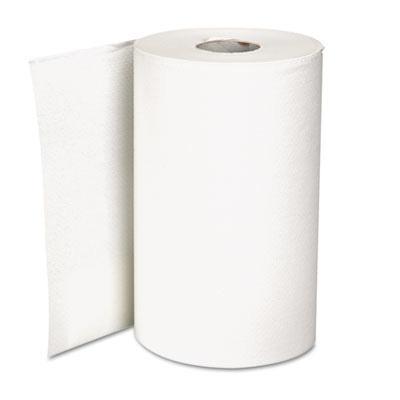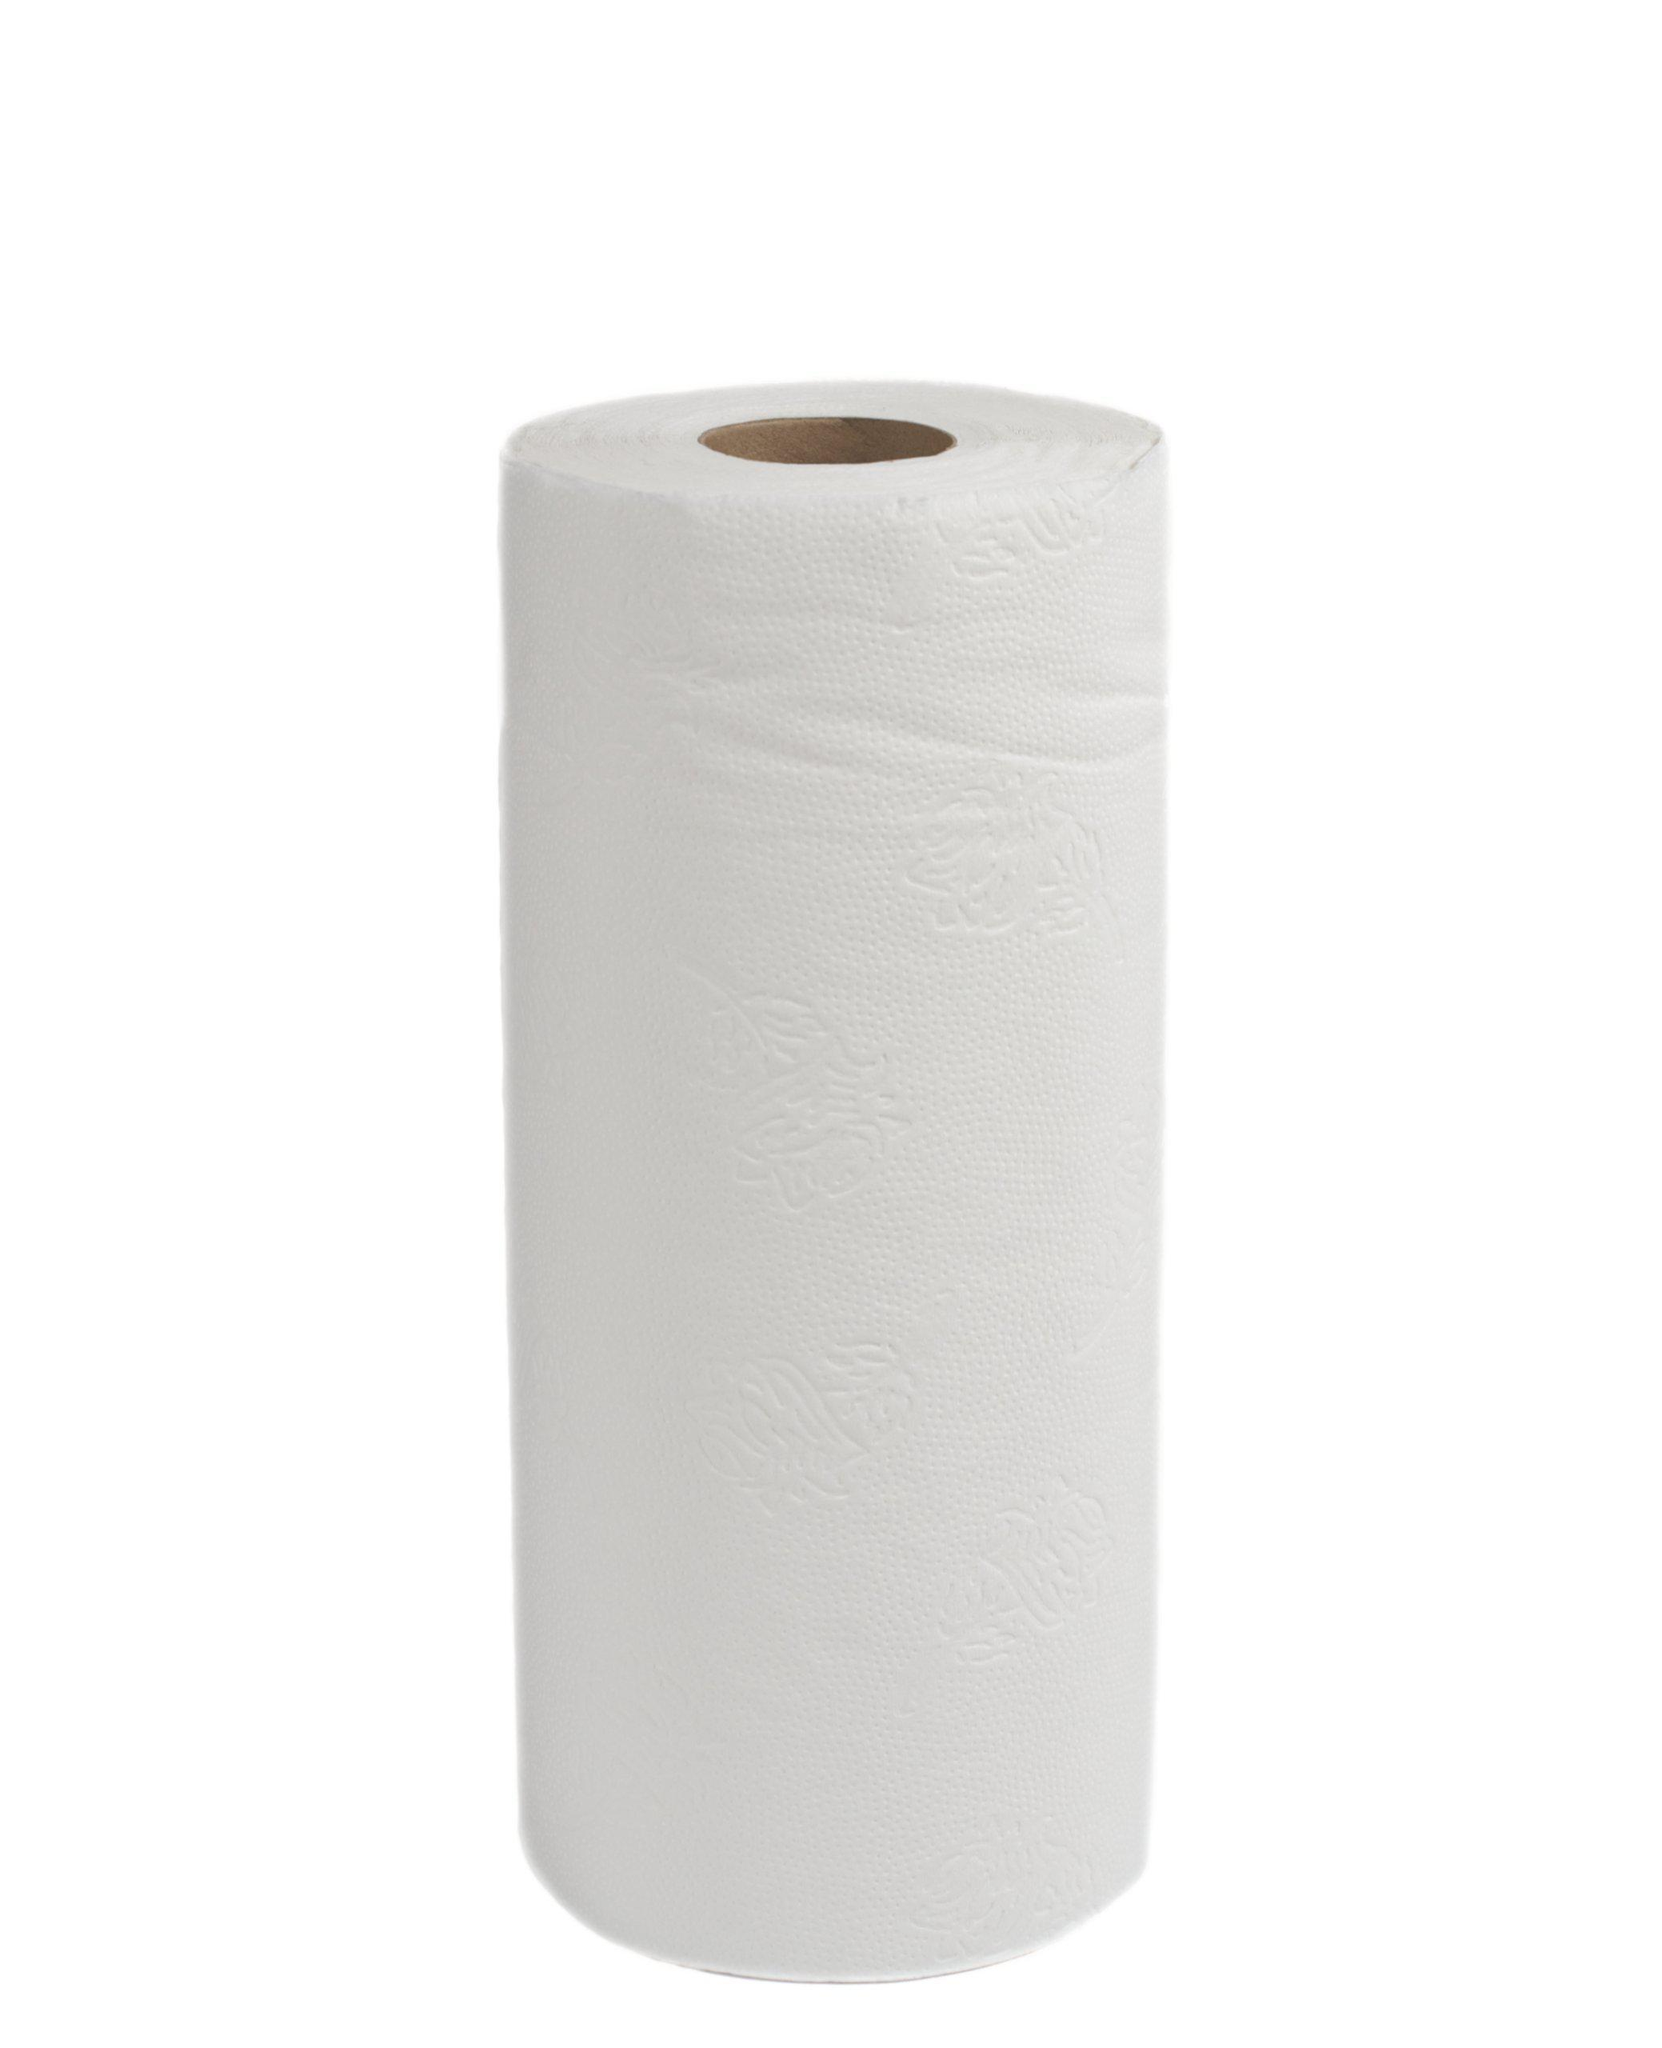The first image is the image on the left, the second image is the image on the right. Analyze the images presented: Is the assertion "All these images contain paper towels standing upright on their rolls." valid? Answer yes or no. Yes. 